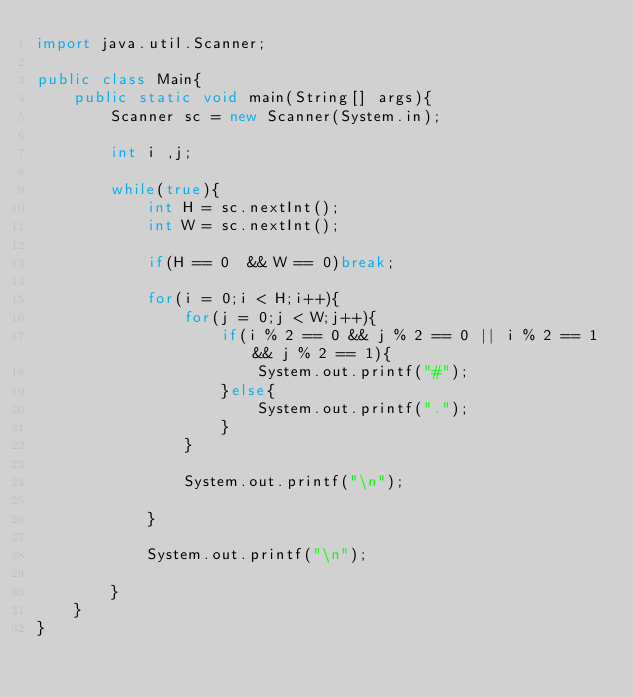<code> <loc_0><loc_0><loc_500><loc_500><_Java_>import java.util.Scanner;

public class Main{
    public static void main(String[] args){
        Scanner sc = new Scanner(System.in);

        int i ,j;

        while(true){
            int H = sc.nextInt();
            int W = sc.nextInt();

            if(H == 0  && W == 0)break;

            for(i = 0;i < H;i++){
                for(j = 0;j < W;j++){
                    if(i % 2 == 0 && j % 2 == 0 || i % 2 == 1 && j % 2 == 1){
                        System.out.printf("#");
                    }else{
                        System.out.printf(".");
                    }
                }

                System.out.printf("\n");

            }

            System.out.printf("\n");

        }
    }
}
</code> 